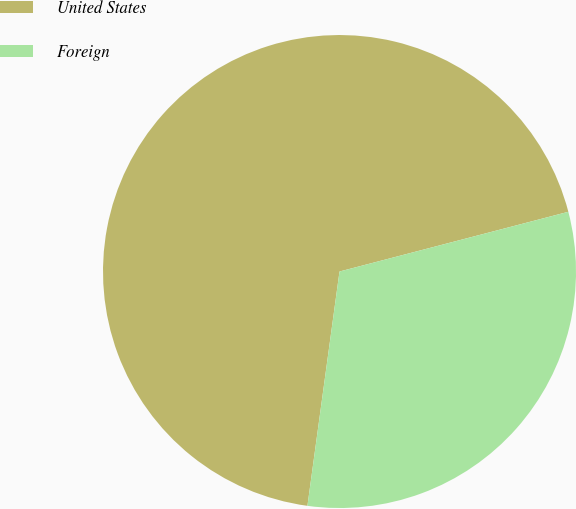Convert chart to OTSL. <chart><loc_0><loc_0><loc_500><loc_500><pie_chart><fcel>United States<fcel>Foreign<nl><fcel>68.77%<fcel>31.23%<nl></chart> 